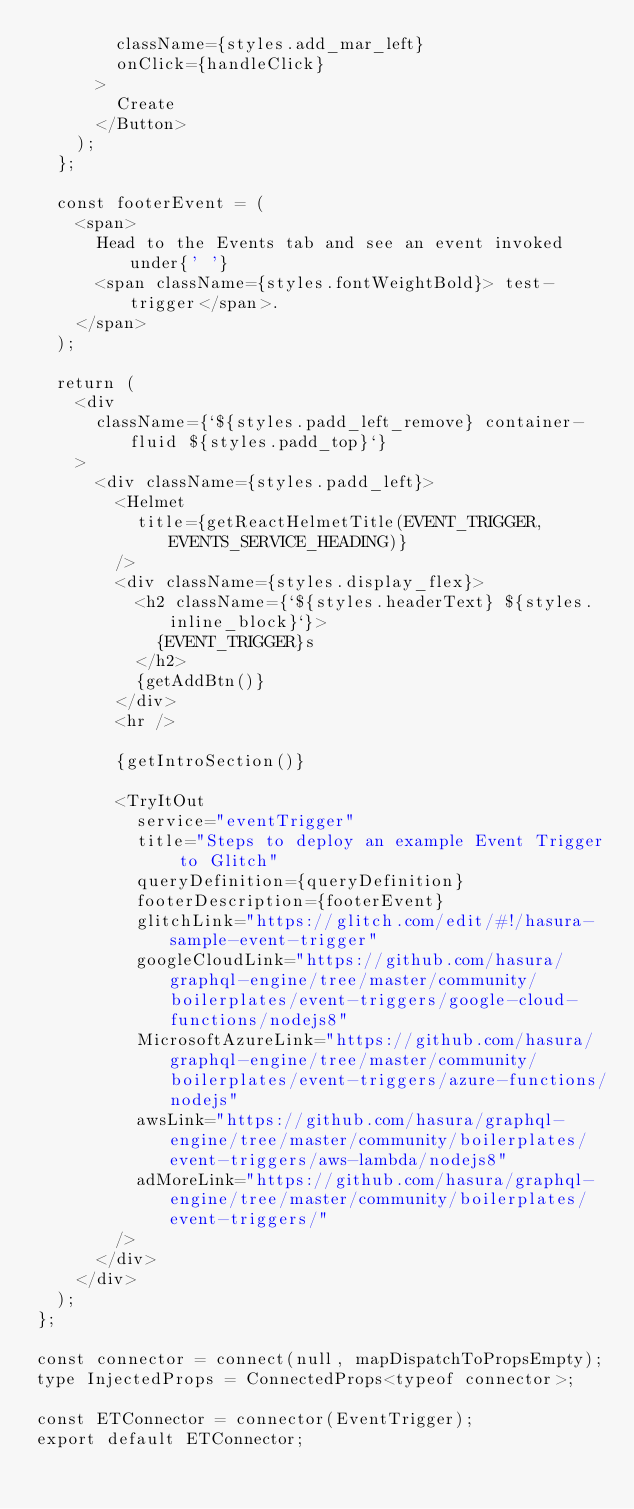<code> <loc_0><loc_0><loc_500><loc_500><_TypeScript_>        className={styles.add_mar_left}
        onClick={handleClick}
      >
        Create
      </Button>
    );
  };

  const footerEvent = (
    <span>
      Head to the Events tab and see an event invoked under{' '}
      <span className={styles.fontWeightBold}> test-trigger</span>.
    </span>
  );

  return (
    <div
      className={`${styles.padd_left_remove} container-fluid ${styles.padd_top}`}
    >
      <div className={styles.padd_left}>
        <Helmet
          title={getReactHelmetTitle(EVENT_TRIGGER, EVENTS_SERVICE_HEADING)}
        />
        <div className={styles.display_flex}>
          <h2 className={`${styles.headerText} ${styles.inline_block}`}>
            {EVENT_TRIGGER}s
          </h2>
          {getAddBtn()}
        </div>
        <hr />

        {getIntroSection()}

        <TryItOut
          service="eventTrigger"
          title="Steps to deploy an example Event Trigger to Glitch"
          queryDefinition={queryDefinition}
          footerDescription={footerEvent}
          glitchLink="https://glitch.com/edit/#!/hasura-sample-event-trigger"
          googleCloudLink="https://github.com/hasura/graphql-engine/tree/master/community/boilerplates/event-triggers/google-cloud-functions/nodejs8"
          MicrosoftAzureLink="https://github.com/hasura/graphql-engine/tree/master/community/boilerplates/event-triggers/azure-functions/nodejs"
          awsLink="https://github.com/hasura/graphql-engine/tree/master/community/boilerplates/event-triggers/aws-lambda/nodejs8"
          adMoreLink="https://github.com/hasura/graphql-engine/tree/master/community/boilerplates/event-triggers/"
        />
      </div>
    </div>
  );
};

const connector = connect(null, mapDispatchToPropsEmpty);
type InjectedProps = ConnectedProps<typeof connector>;

const ETConnector = connector(EventTrigger);
export default ETConnector;
</code> 